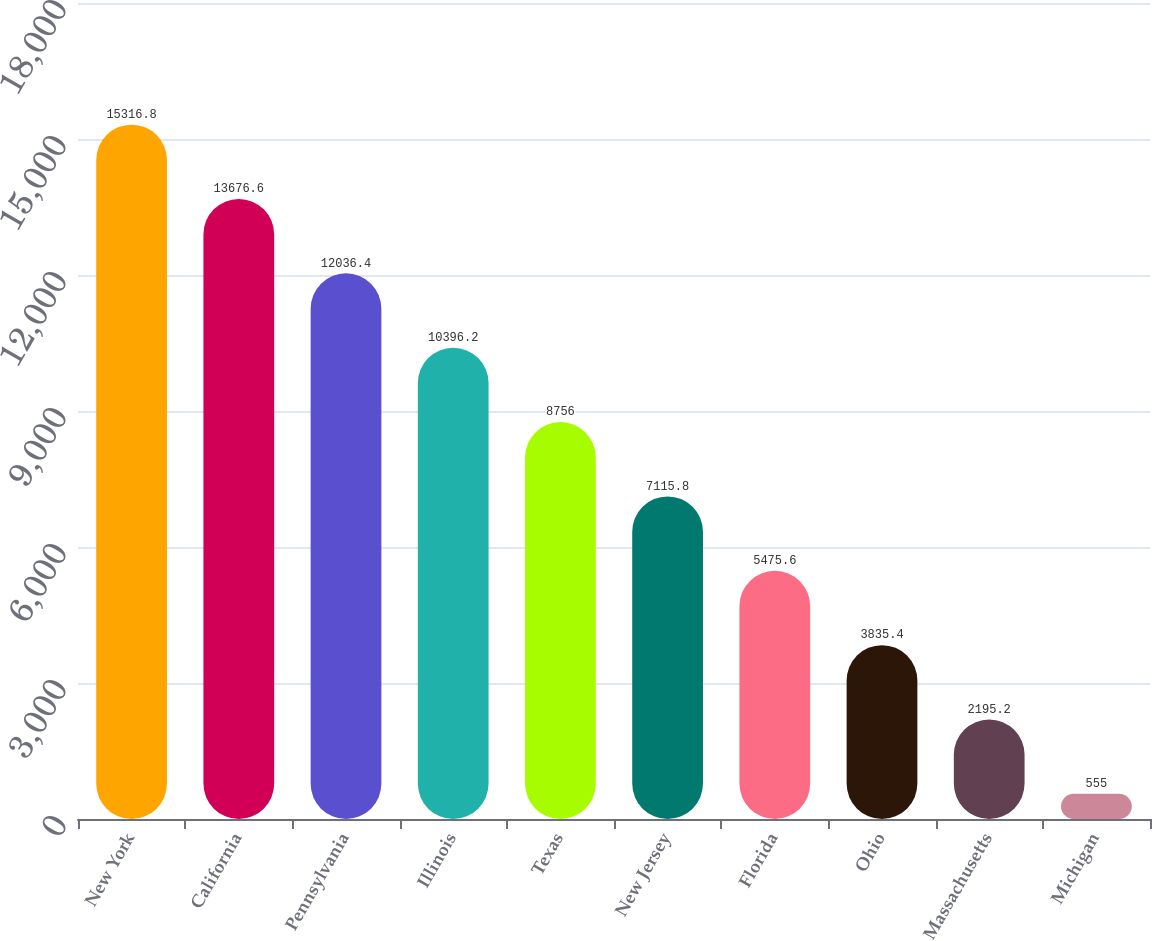Convert chart. <chart><loc_0><loc_0><loc_500><loc_500><bar_chart><fcel>New York<fcel>California<fcel>Pennsylvania<fcel>Illinois<fcel>Texas<fcel>New Jersey<fcel>Florida<fcel>Ohio<fcel>Massachusetts<fcel>Michigan<nl><fcel>15316.8<fcel>13676.6<fcel>12036.4<fcel>10396.2<fcel>8756<fcel>7115.8<fcel>5475.6<fcel>3835.4<fcel>2195.2<fcel>555<nl></chart> 